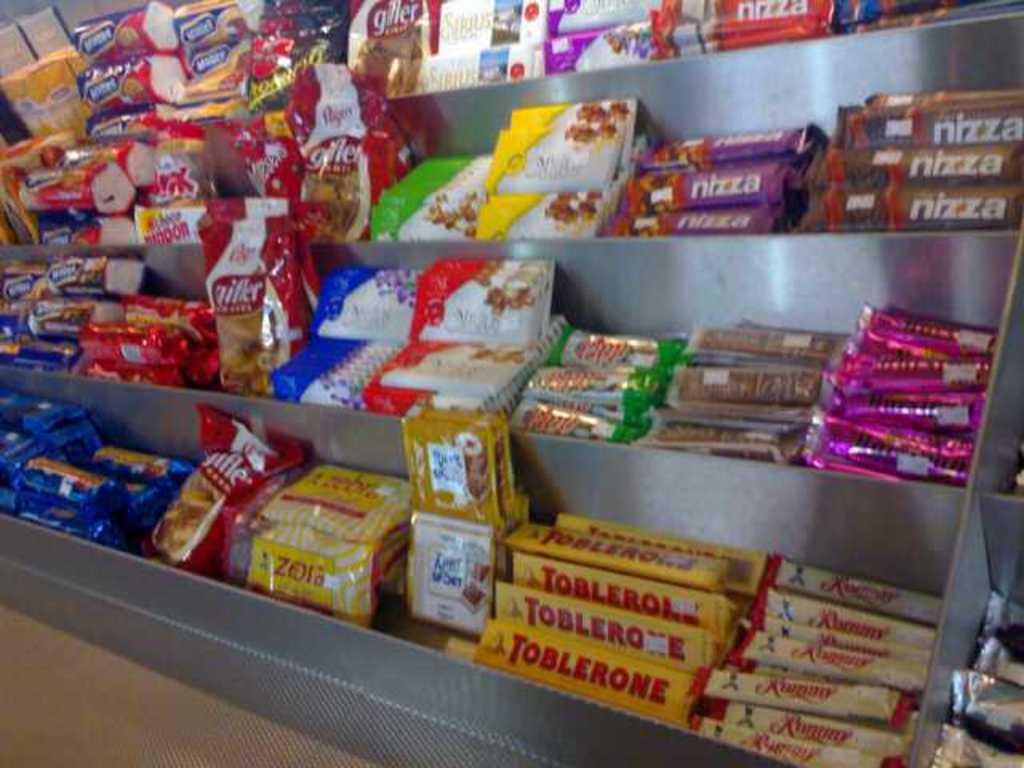What is the name of the candy in the yellow packages with red lettering?
Provide a succinct answer. Toblerone. What is the name of the candy in the long yellow box?
Give a very brief answer. Toblerone. 